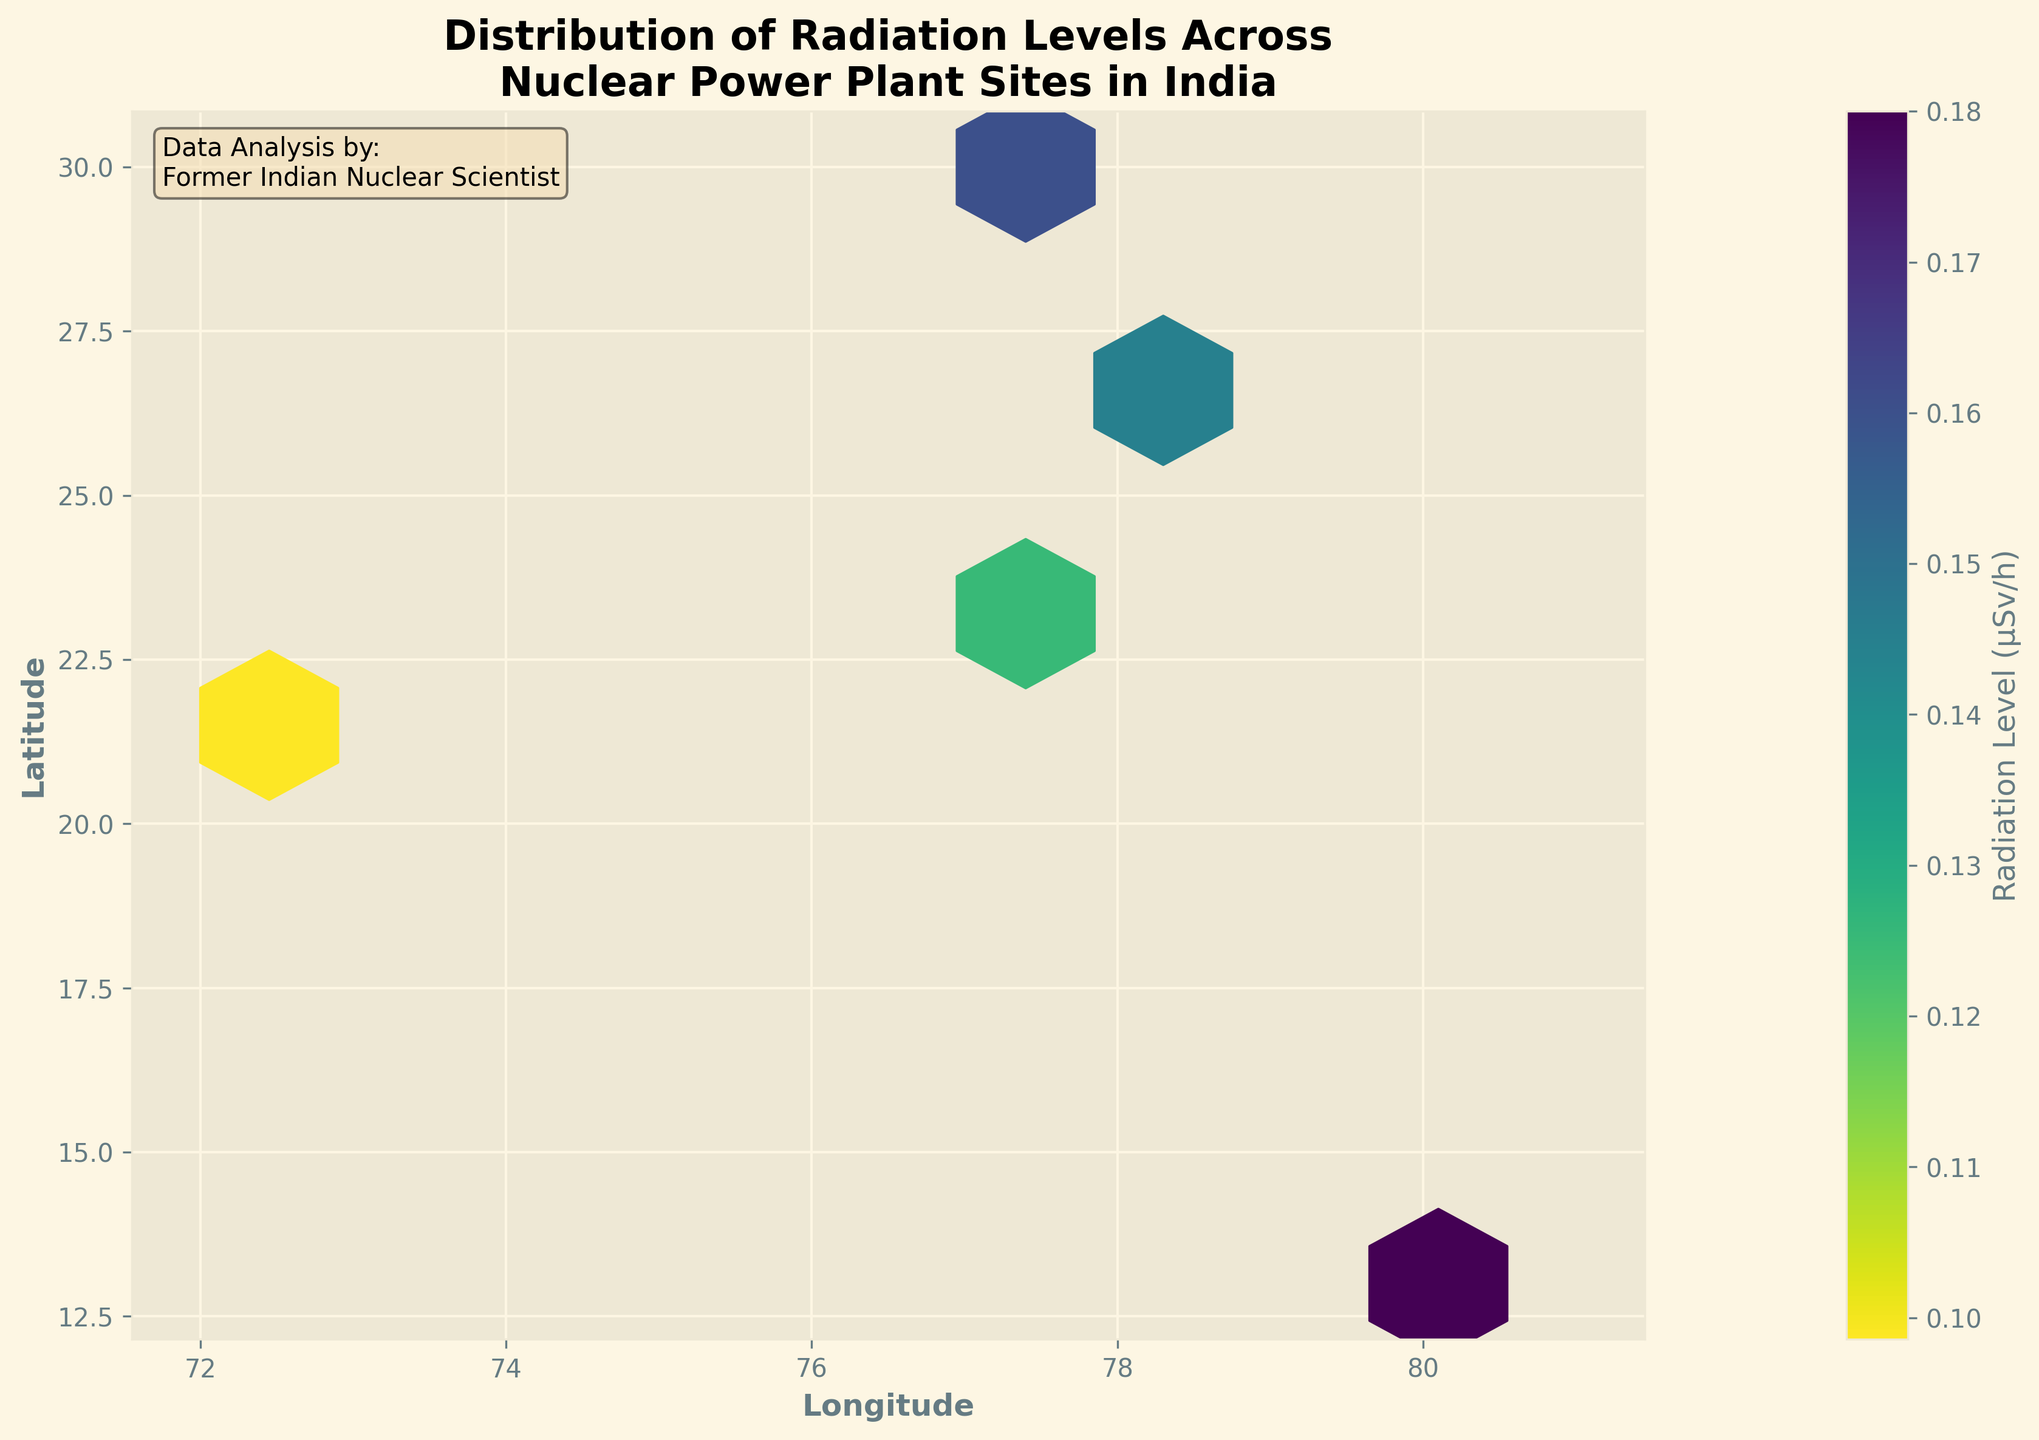What is the title of the plot? The title of the plot is displayed at the top and reads "Distribution of Radiation Levels Across Nuclear Power Plant Sites in India".
Answer: Distribution of Radiation Levels Across Nuclear Power Plant Sites in India What does the color bar represent in the plot? The color bar represents the radiation levels, measured in µSv/h, with varying colors indicating different radiation intensities from low to high.
Answer: Radiation Level (µSv/h) What are the x-axis and y-axis labels in the plot? The x-axis is labeled "Longitude" and the y-axis is labeled "Latitude", which indicate the geographical coordinates of the nuclear power plant sites.
Answer: Longitude and Latitude In which longitude range are the nuclear power plant sites distributed? The plot's x-axis spans from approximately 72 to 81, indicating the sites are distributed within this longitude range.
Answer: 72 to 81 Is there any location on the plot with the highest concentration of radiation levels? The hexbin plot color intensity reveals the highest concentration of radiation levels, identified by the darkest color in the regions around longitude 80 and latitude 13.
Answer: Yes, around longitude 80 and latitude 13 Which region shows the lowest radiation levels? The lightest-colored hexagonal bins on the plot signify the lowest radiation levels, predominantly found around longitudes 72 and latitudes around 22.
Answer: Longitudes around 72 and latitudes around 22 How do the radiation levels vary between northern and southern parts of the plotted region? By comparing the color intensity in the northern and southern parts, it appears that the southern region (around latitude 13) has higher radiation levels compared to the northern region (around latitude 29).
Answer: Higher in the southern region What is the average radiation level at longitudes around 77? Identify the hexagonal bins around longitudes 77 and estimate an average based on the color intensity shown in the color bar. This requires multiple comparisons across these bins.
Answer: Approximately 0.12 - 0.16 µSv/h Which latitude shows more variance in radiation levels, 22 or 26? Compare the color variations along the latitude lines of 22 and 26. The 22-latitude line has both very light and moderately dark colors, showing more variance than the relatively consistent colors along the 26-latitude line.
Answer: Latitude 22 Is there a correlation between geographic location and radiation levels? Analyze the distribution and color intensity patterns across different geographical locations on the plot. The plot suggests a clear correlation where certain longitudes and latitudes show more consistent patterns of radiation intensity.
Answer: Yes, there is a correlation 